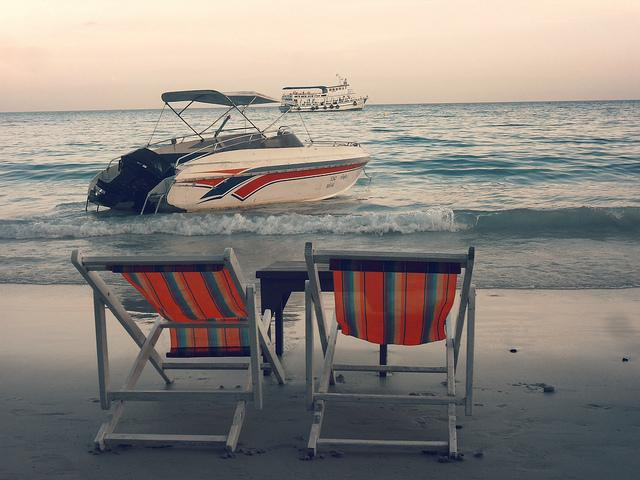What does the boat at the water's edge run on? gas 